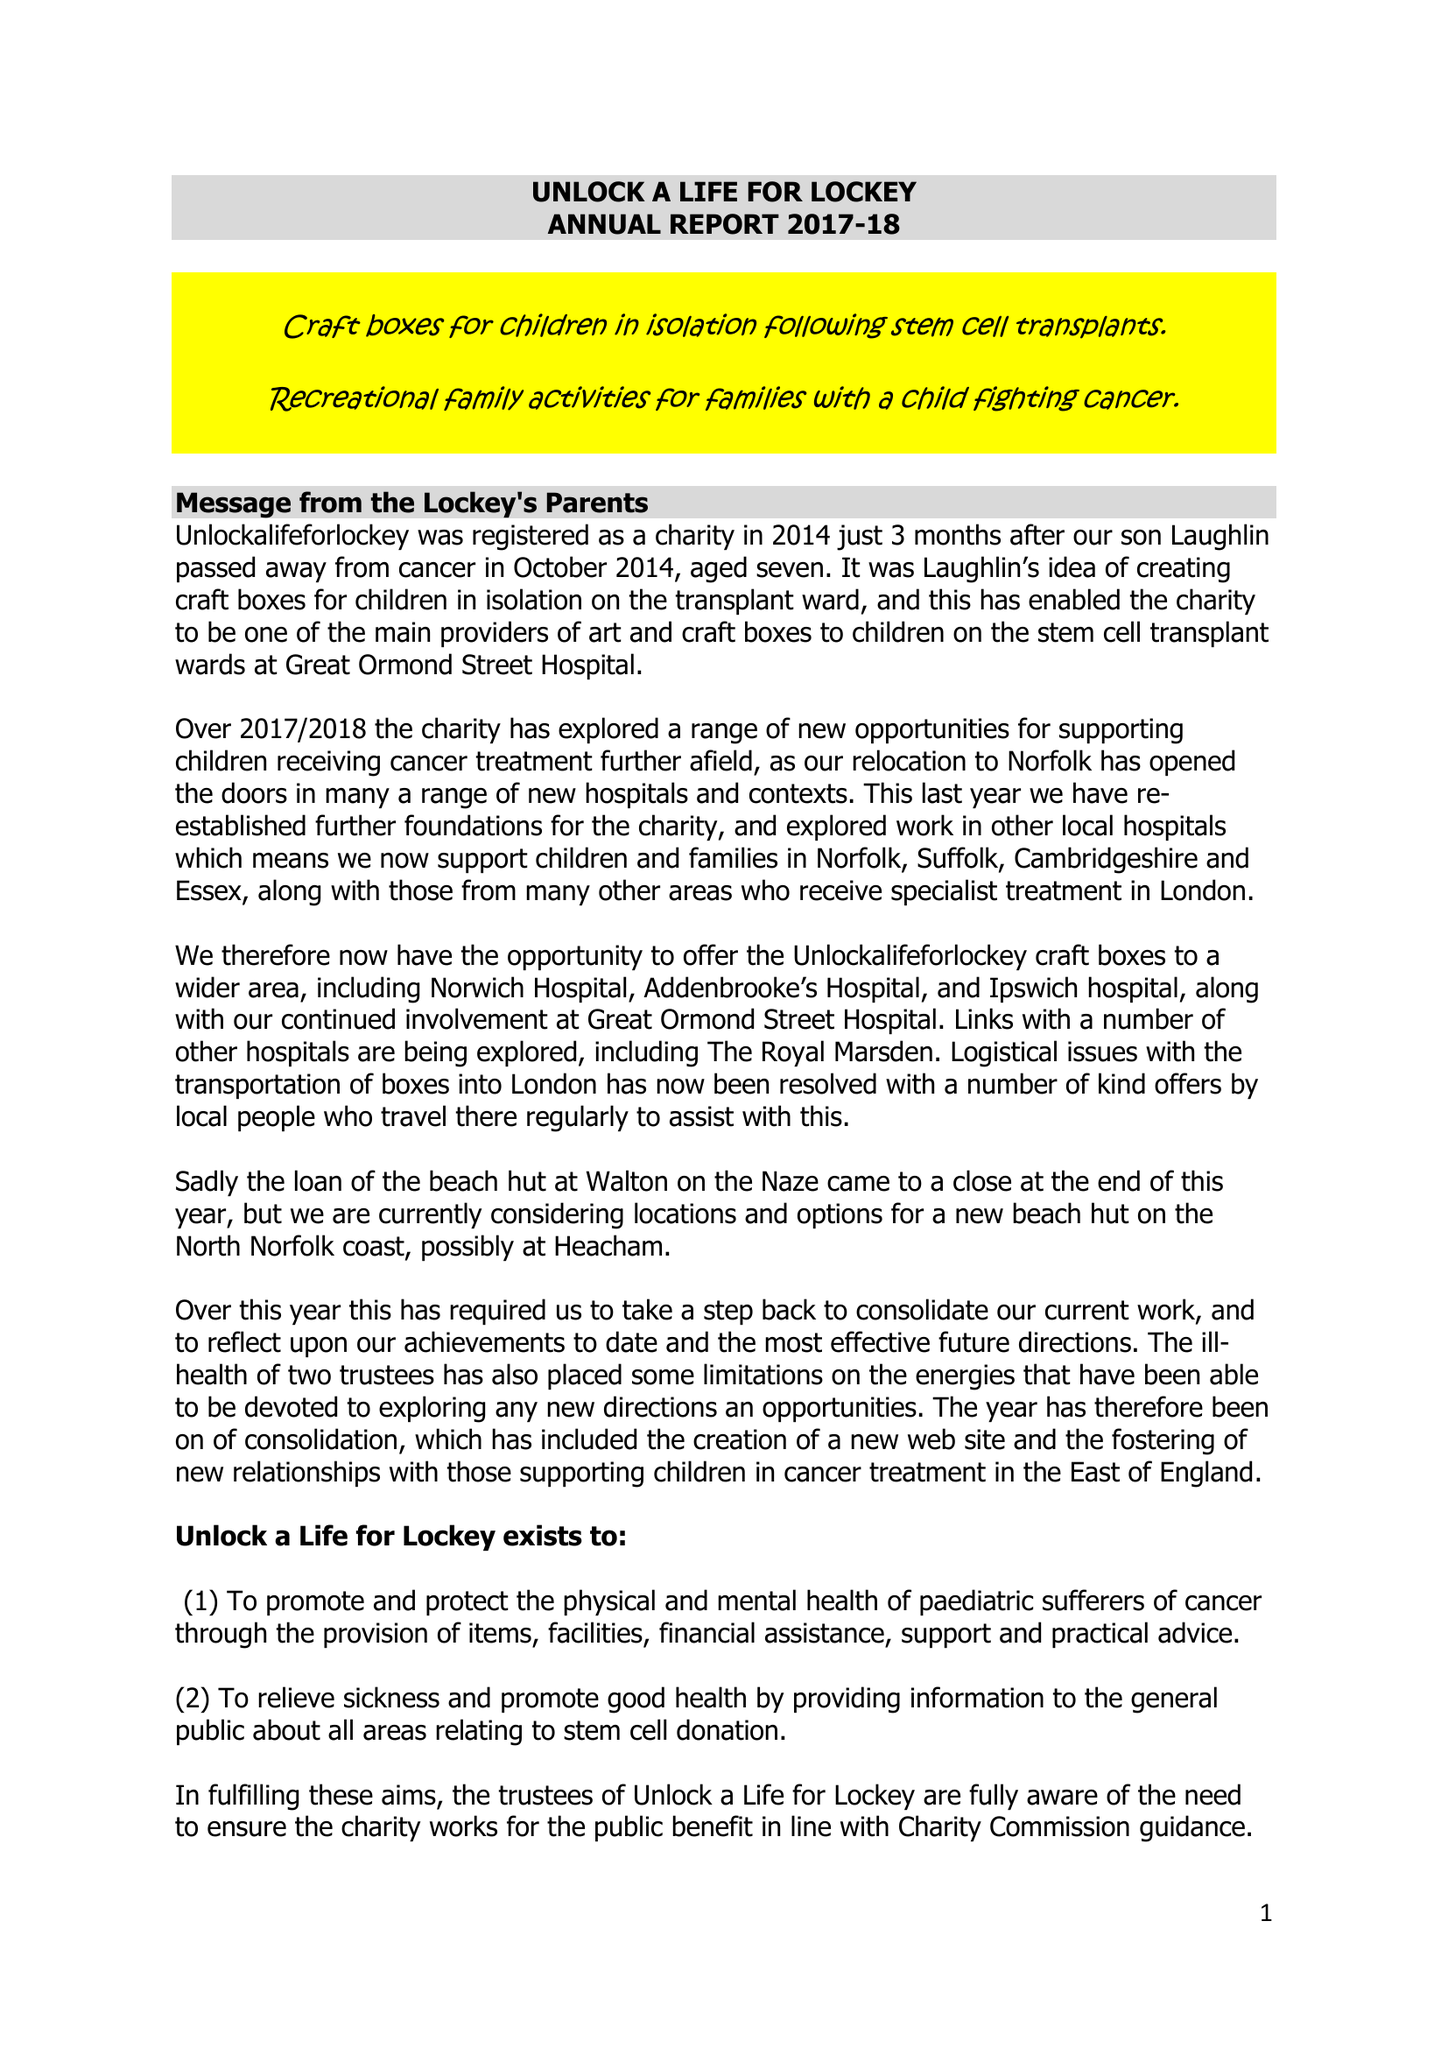What is the value for the spending_annually_in_british_pounds?
Answer the question using a single word or phrase. 573.00 